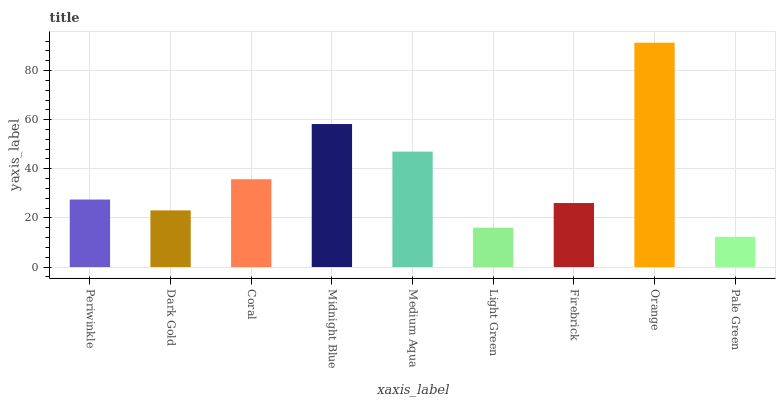Is Pale Green the minimum?
Answer yes or no. Yes. Is Orange the maximum?
Answer yes or no. Yes. Is Dark Gold the minimum?
Answer yes or no. No. Is Dark Gold the maximum?
Answer yes or no. No. Is Periwinkle greater than Dark Gold?
Answer yes or no. Yes. Is Dark Gold less than Periwinkle?
Answer yes or no. Yes. Is Dark Gold greater than Periwinkle?
Answer yes or no. No. Is Periwinkle less than Dark Gold?
Answer yes or no. No. Is Periwinkle the high median?
Answer yes or no. Yes. Is Periwinkle the low median?
Answer yes or no. Yes. Is Light Green the high median?
Answer yes or no. No. Is Light Green the low median?
Answer yes or no. No. 